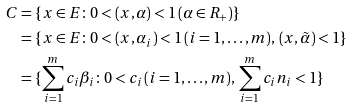<formula> <loc_0><loc_0><loc_500><loc_500>C & = \{ x \in E \colon 0 < ( x , \alpha ) < 1 \, ( \alpha \in R _ { + } ) \} \\ & = \{ x \in E \colon 0 < ( x , \alpha _ { i } ) < 1 \, ( i = 1 , \dots , m ) , \, ( x , \tilde { \alpha } ) < 1 \} \\ & = \{ \sum _ { i = 1 } ^ { m } c _ { i } \beta _ { i } \colon 0 < c _ { i } \, ( i = 1 , \dots , m ) , \, \sum _ { i = 1 } ^ { m } c _ { i } n _ { i } < 1 \}</formula> 